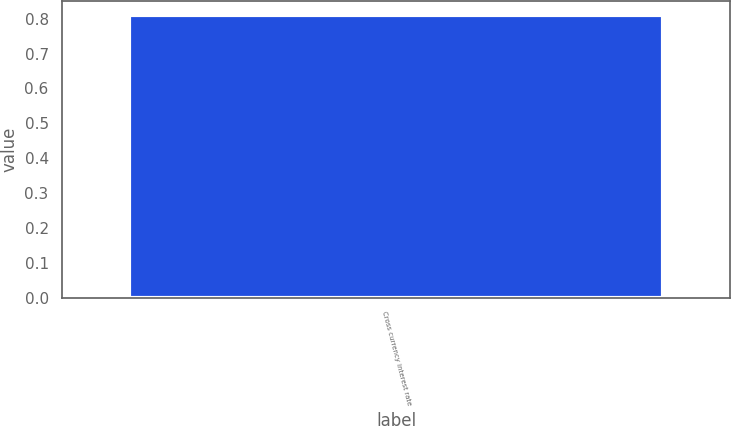<chart> <loc_0><loc_0><loc_500><loc_500><bar_chart><fcel>Cross currency interest rate<nl><fcel>0.81<nl></chart> 